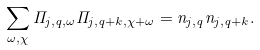<formula> <loc_0><loc_0><loc_500><loc_500>\sum _ { \omega , \chi } \Pi _ { j , q , \omega } \Pi _ { j , q + k , \chi + \omega } = n _ { j , q } n _ { j , q + k } .</formula> 